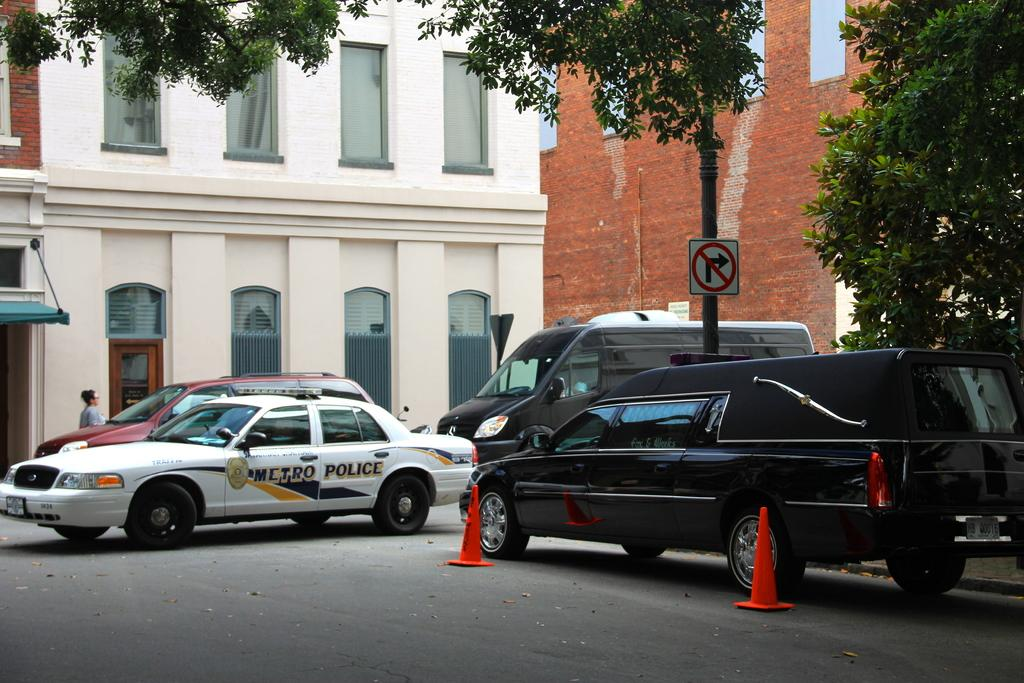What types of vehicles can be seen in the image? There are vehicles in the image, but the specific types are not mentioned. What objects are used to direct traffic in the image? Traffic cones are present in the image. What is the setting of the image? There is a road in the image, which suggests the image is set in an outdoor or urban environment. Can you describe the person in the image? There is a person in the image, but their appearance or actions are not mentioned. What structures are visible in the image? There is a building in the image. What type of vegetation is present in the image? Trees are present in the image. What type of butter is being used to stop the traffic in the image? There is no butter present in the image, and traffic cones are used to direct traffic instead. 